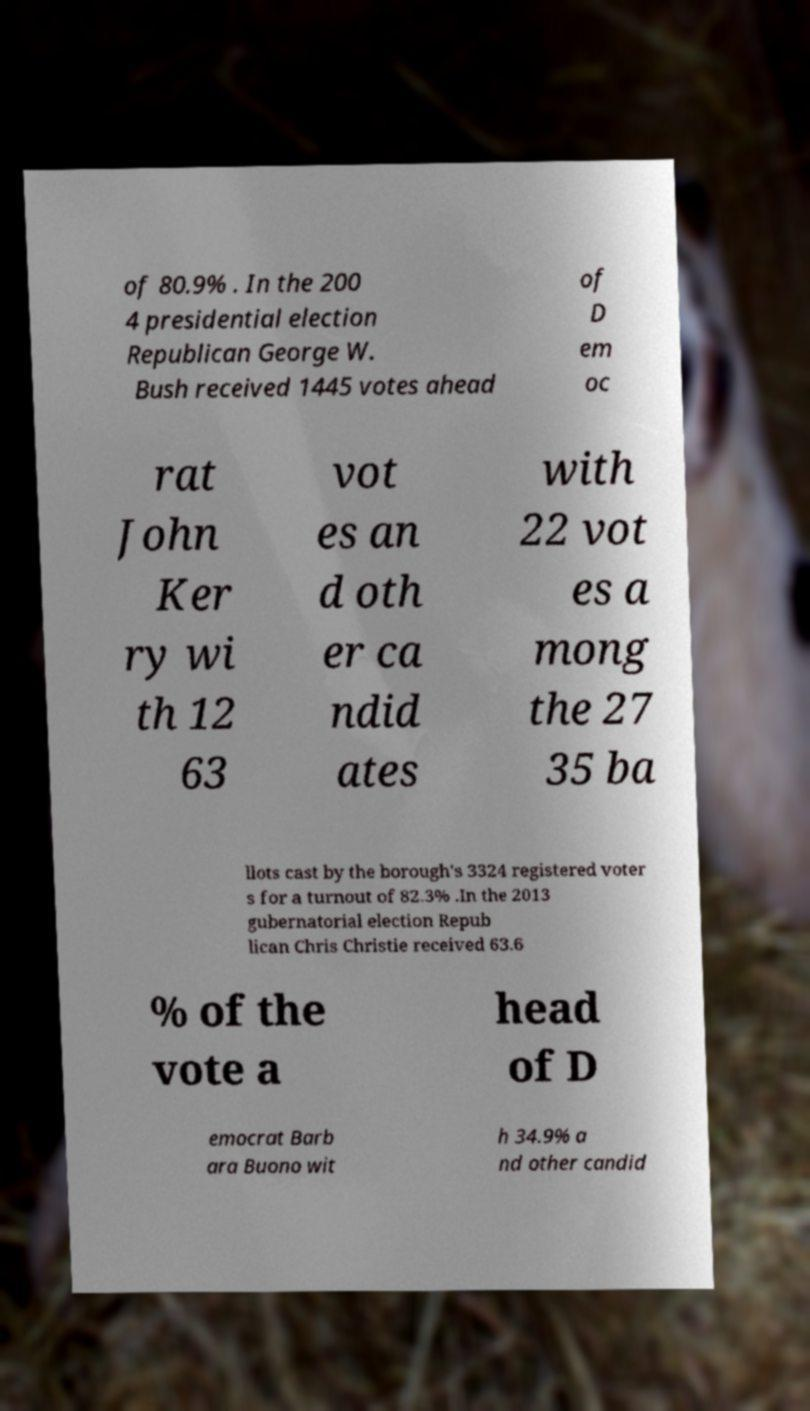Can you read and provide the text displayed in the image?This photo seems to have some interesting text. Can you extract and type it out for me? of 80.9% . In the 200 4 presidential election Republican George W. Bush received 1445 votes ahead of D em oc rat John Ker ry wi th 12 63 vot es an d oth er ca ndid ates with 22 vot es a mong the 27 35 ba llots cast by the borough's 3324 registered voter s for a turnout of 82.3% .In the 2013 gubernatorial election Repub lican Chris Christie received 63.6 % of the vote a head of D emocrat Barb ara Buono wit h 34.9% a nd other candid 